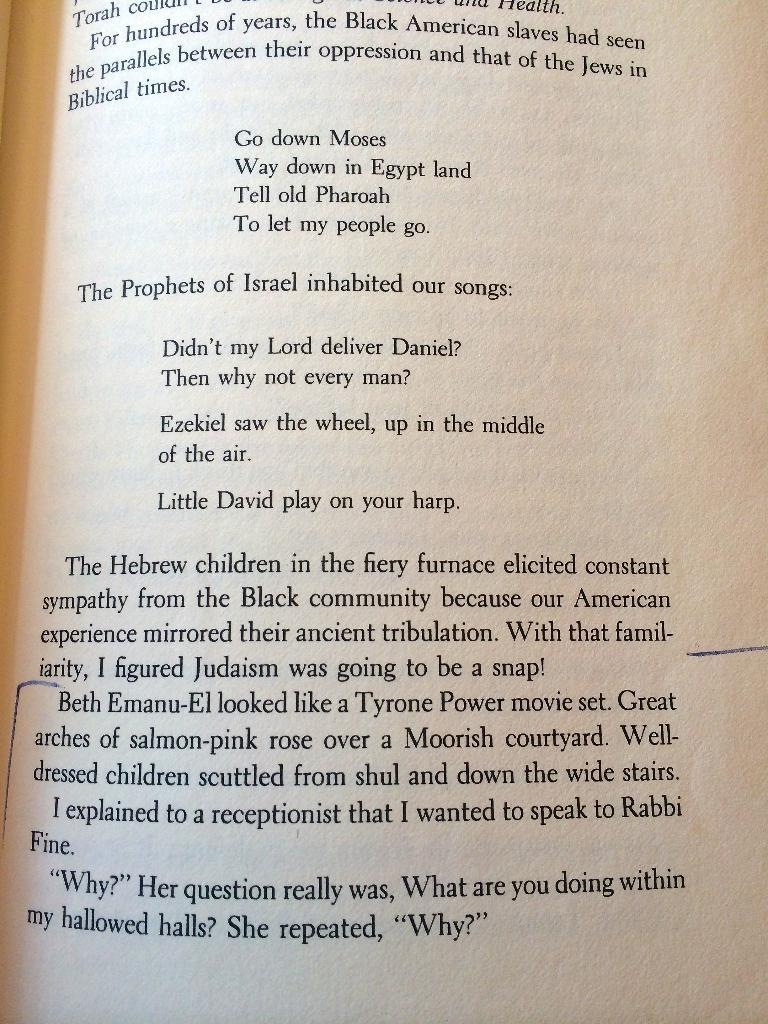<image>
Summarize the visual content of the image. A book opened to a page with a line drawn to the left side of Beth Emanu-El's name. 